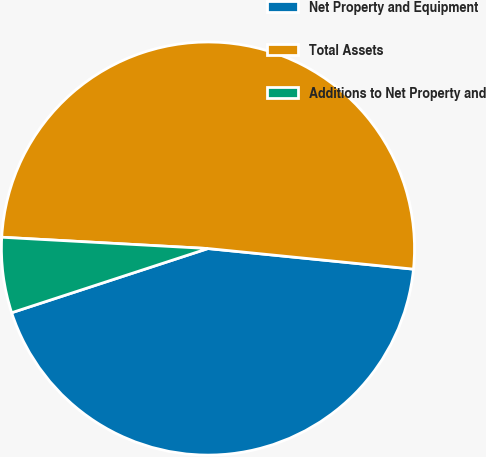Convert chart to OTSL. <chart><loc_0><loc_0><loc_500><loc_500><pie_chart><fcel>Net Property and Equipment<fcel>Total Assets<fcel>Additions to Net Property and<nl><fcel>43.38%<fcel>50.72%<fcel>5.9%<nl></chart> 